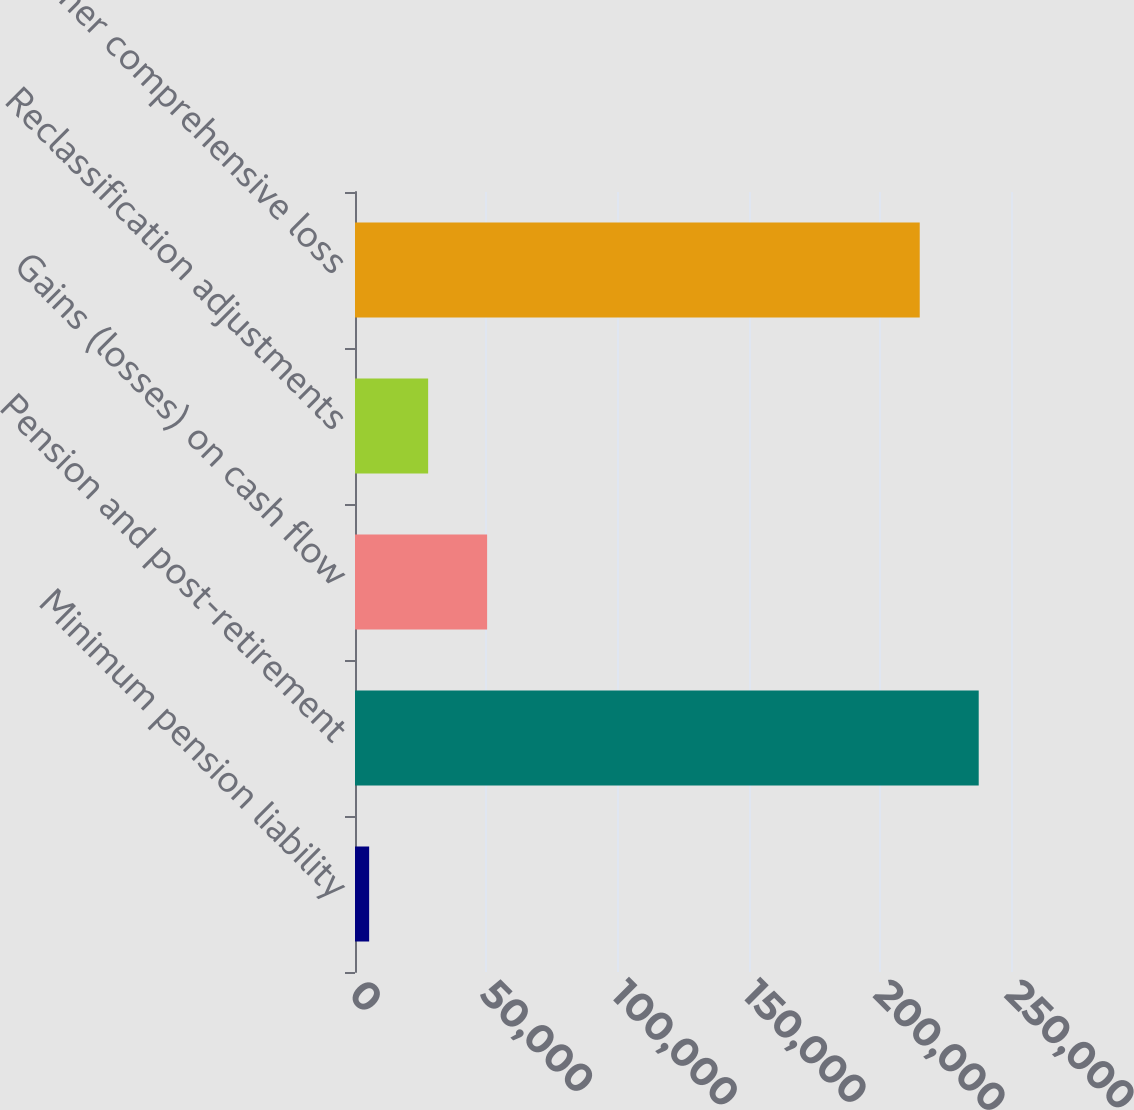<chart> <loc_0><loc_0><loc_500><loc_500><bar_chart><fcel>Minimum pension liability<fcel>Pension and post-retirement<fcel>Gains (losses) on cash flow<fcel>Reclassification adjustments<fcel>Total other comprehensive loss<nl><fcel>5395<fcel>237694<fcel>50350<fcel>27872.5<fcel>215217<nl></chart> 